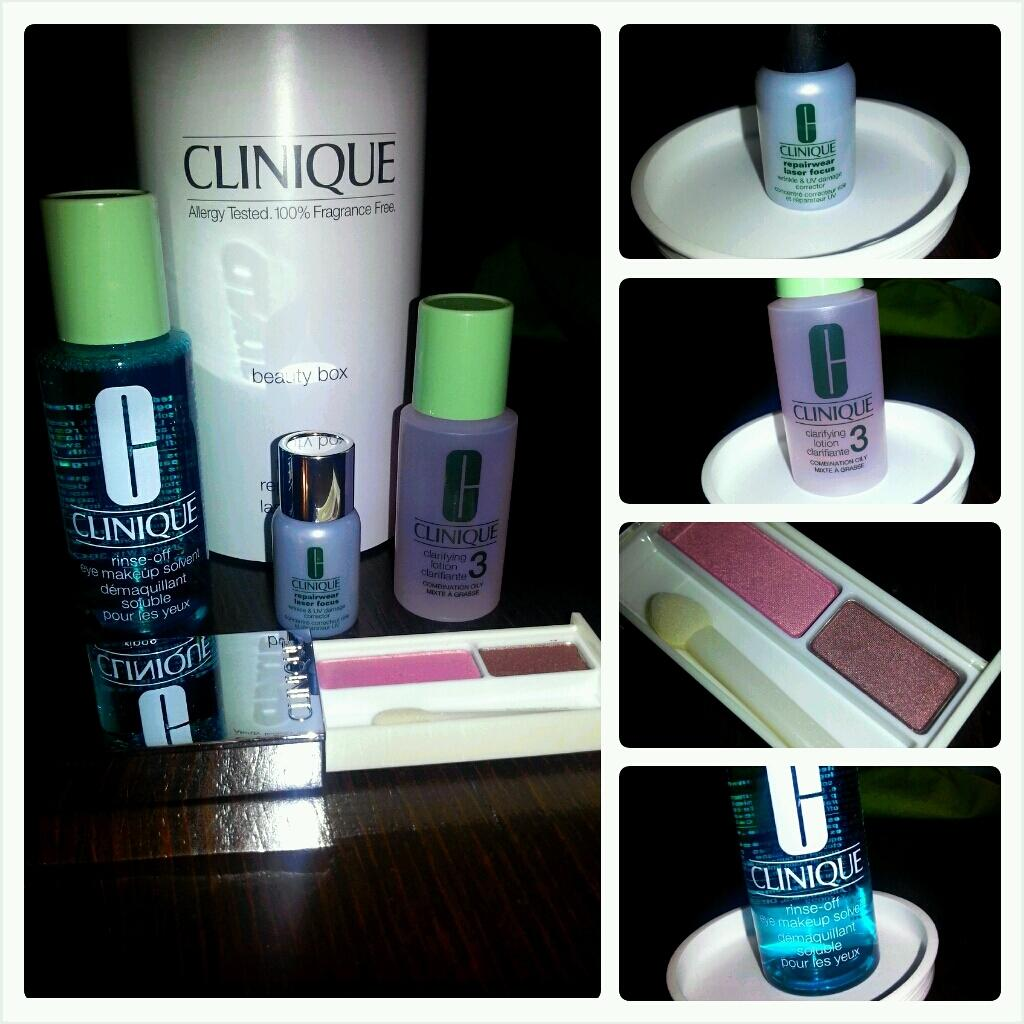What objects can be seen on the table in the image? There are bottles and a makeup kit on the table in the image. What might the bottles contain? The bottles might contain various liquids or substances, but their contents are not specified in the image. What is the purpose of the makeup kit? The makeup kit is likely used for applying makeup or cosmetics. What type of humor can be seen in the image? There is no humor present in the image; it simply shows bottles and a makeup kit on a table. Can you tell me how many geese are in the image? There are no geese present in the image. 